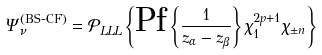<formula> <loc_0><loc_0><loc_500><loc_500>\Psi _ { \nu } ^ { \left ( \text {BS-CF} \right ) } = \mathcal { P } _ { L L L } \left \{ \text {Pf} \left \{ \frac { 1 } { z _ { \alpha } - z _ { \beta } } \right \} \chi _ { 1 } ^ { 2 p + 1 } \chi _ { \pm n } \right \}</formula> 